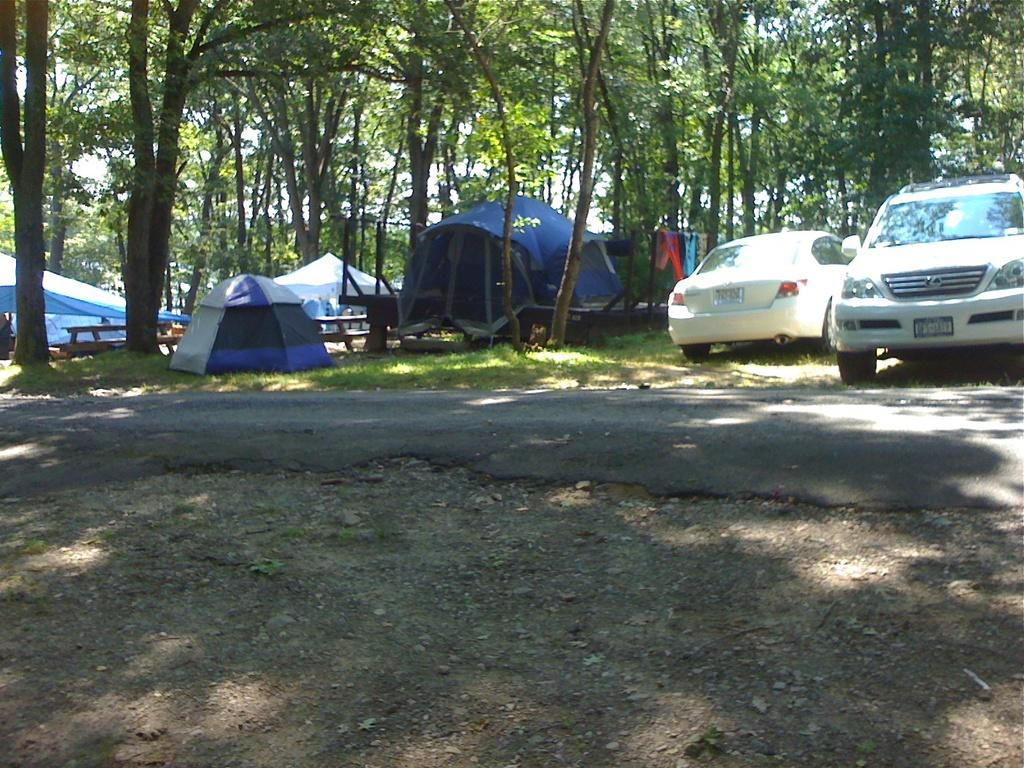What type of pathway is visible in the image? There is a road in the image. What can be found on the ground near the road? There are stones on the ground. What is located on the right side of the image? There are vehicles on the right side of the image. What type of temporary shelter is present in the image? There are tents in the image. What type of vegetation is visible in the image? There are trees in the image. Where is the dock located in the image? There is no dock present in the image. 